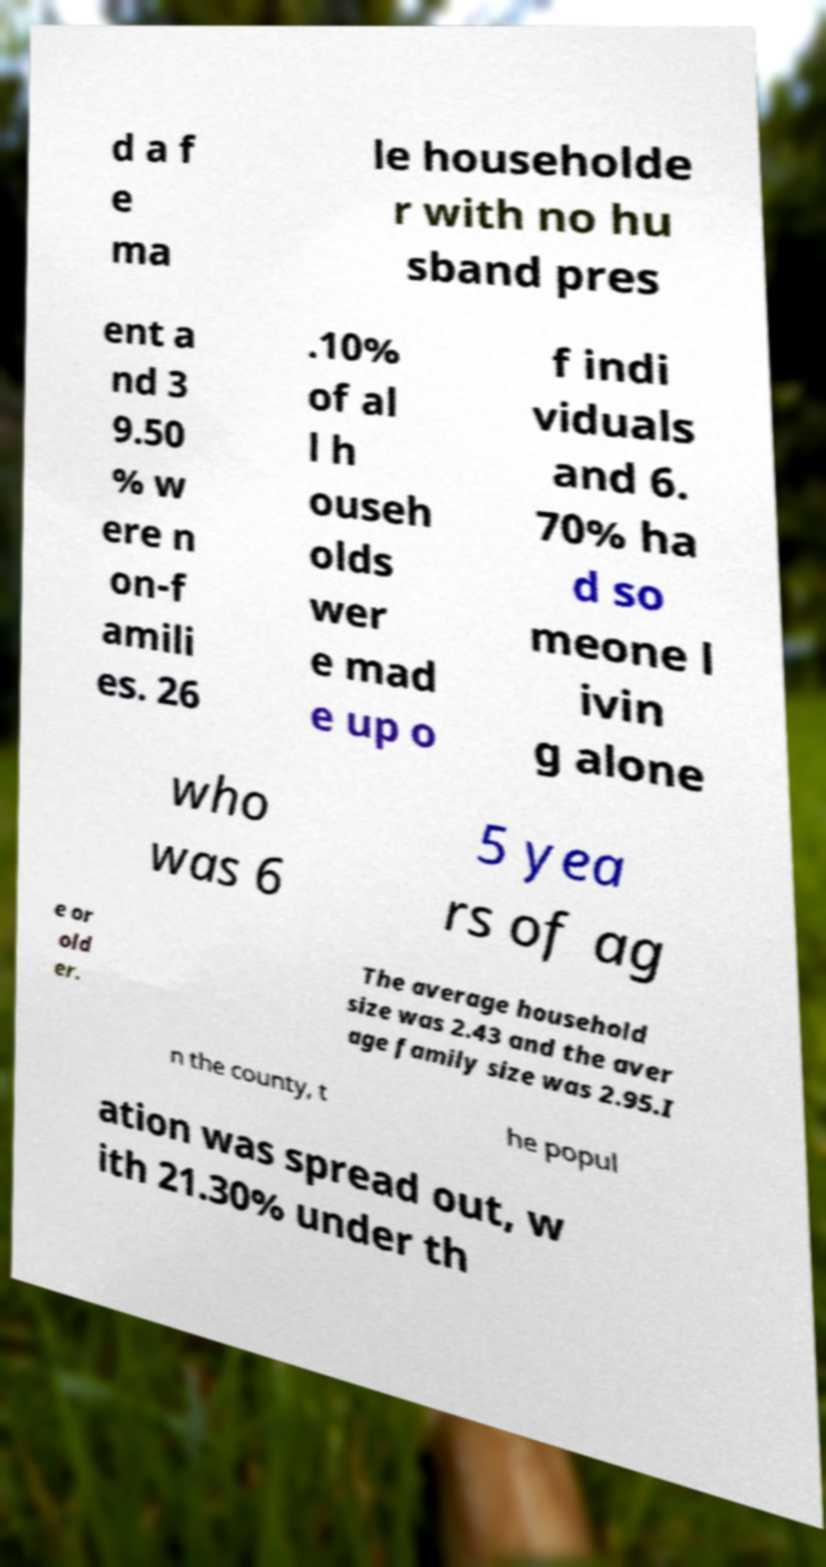Could you extract and type out the text from this image? d a f e ma le householde r with no hu sband pres ent a nd 3 9.50 % w ere n on-f amili es. 26 .10% of al l h ouseh olds wer e mad e up o f indi viduals and 6. 70% ha d so meone l ivin g alone who was 6 5 yea rs of ag e or old er. The average household size was 2.43 and the aver age family size was 2.95.I n the county, t he popul ation was spread out, w ith 21.30% under th 